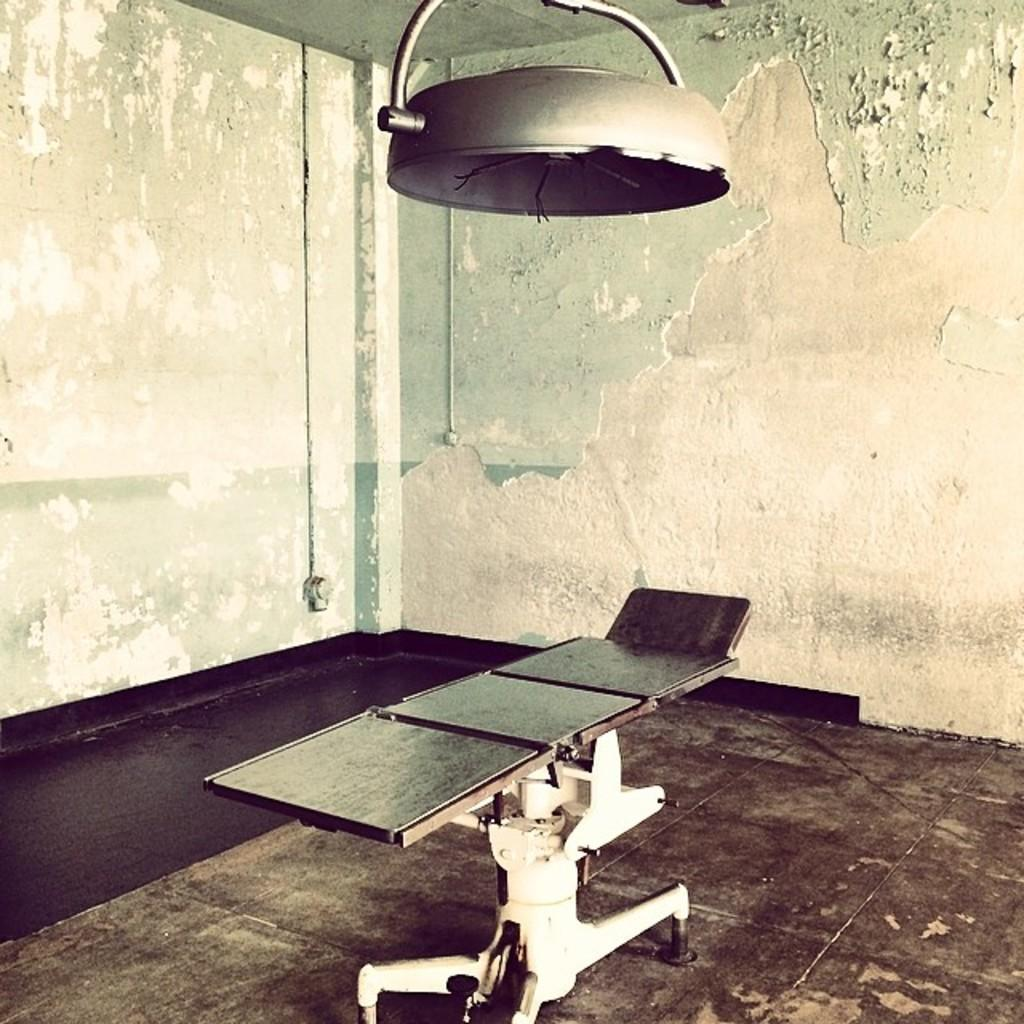What type of furniture is present in the image? There is a table in the image. Where is the table located? The table is placed on the floor. What can be seen in the image that provides illumination? There is a light in the image. What type of structure is visible in the background? There is a wall in the image. Where is the locket hanging in the image? There is no locket present in the image. What type of bird's nest can be seen on the wall in the image? There is no bird's nest present in the image. 